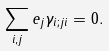<formula> <loc_0><loc_0><loc_500><loc_500>\sum _ { i , j } e _ { j } \gamma _ { i ; j i } = 0 .</formula> 